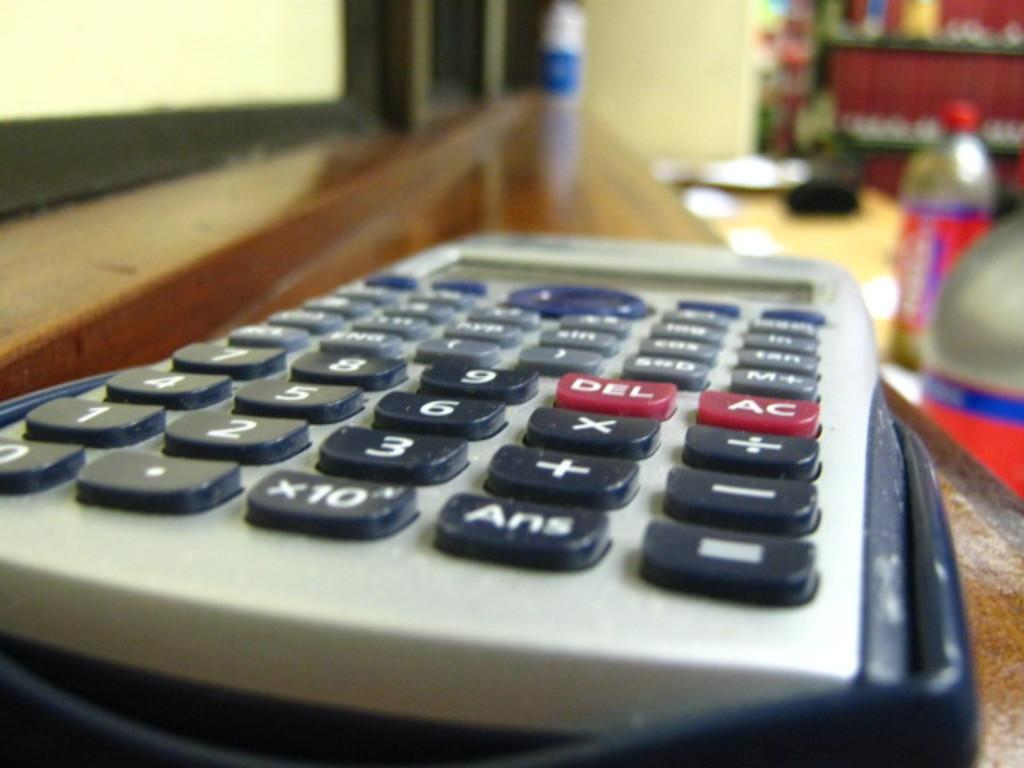<image>
Offer a succinct explanation of the picture presented. the number 6 is on the front of the calculator 